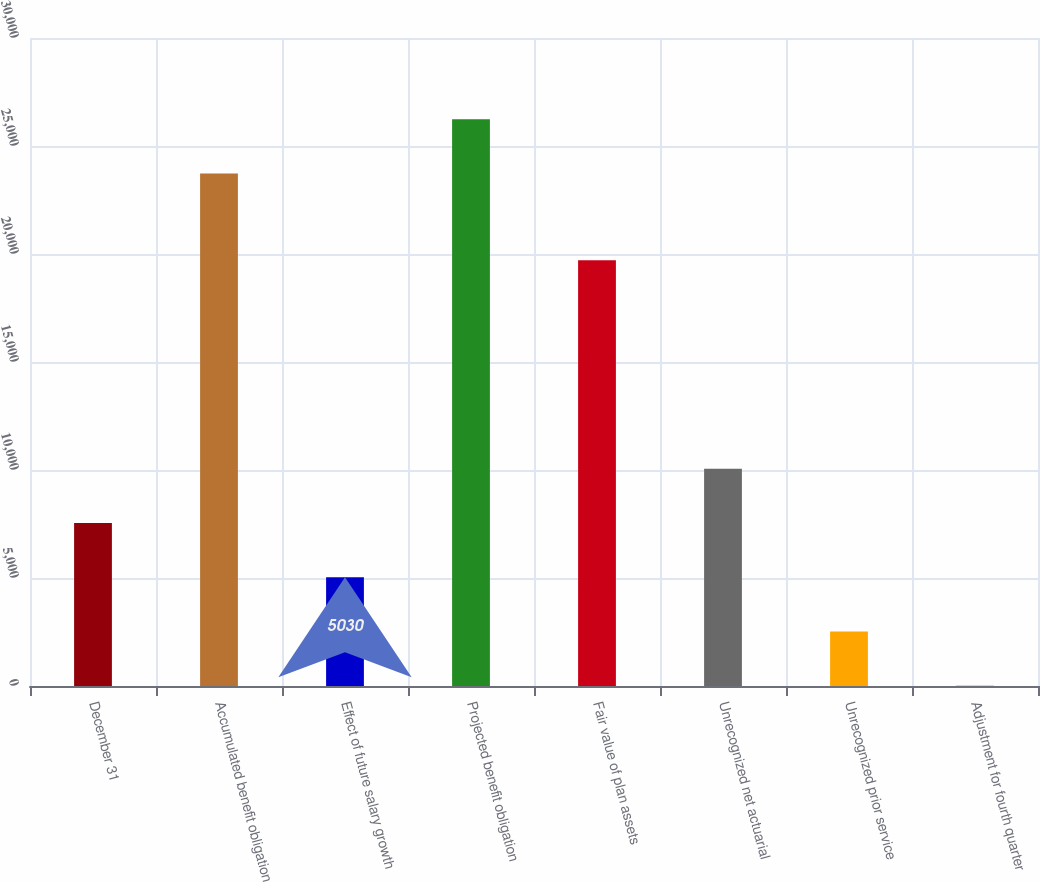<chart> <loc_0><loc_0><loc_500><loc_500><bar_chart><fcel>December 31<fcel>Accumulated benefit obligation<fcel>Effect of future salary growth<fcel>Projected benefit obligation<fcel>Fair value of plan assets<fcel>Unrecognized net actuarial<fcel>Unrecognized prior service<fcel>Adjustment for fourth quarter<nl><fcel>7541.5<fcel>23729<fcel>5030<fcel>26240.5<fcel>19709<fcel>10053<fcel>2518.5<fcel>7<nl></chart> 